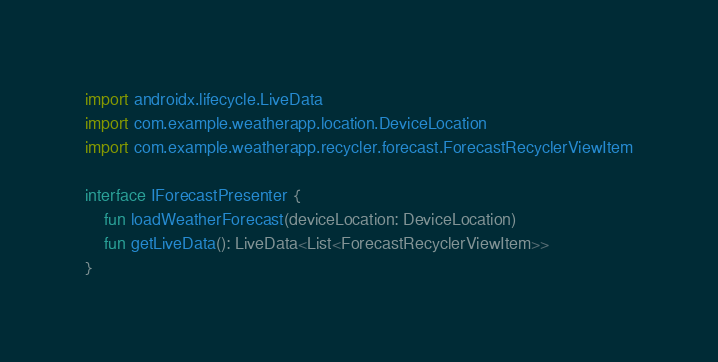Convert code to text. <code><loc_0><loc_0><loc_500><loc_500><_Kotlin_>import androidx.lifecycle.LiveData
import com.example.weatherapp.location.DeviceLocation
import com.example.weatherapp.recycler.forecast.ForecastRecyclerViewItem

interface IForecastPresenter {
    fun loadWeatherForecast(deviceLocation: DeviceLocation)
    fun getLiveData(): LiveData<List<ForecastRecyclerViewItem>>
}</code> 